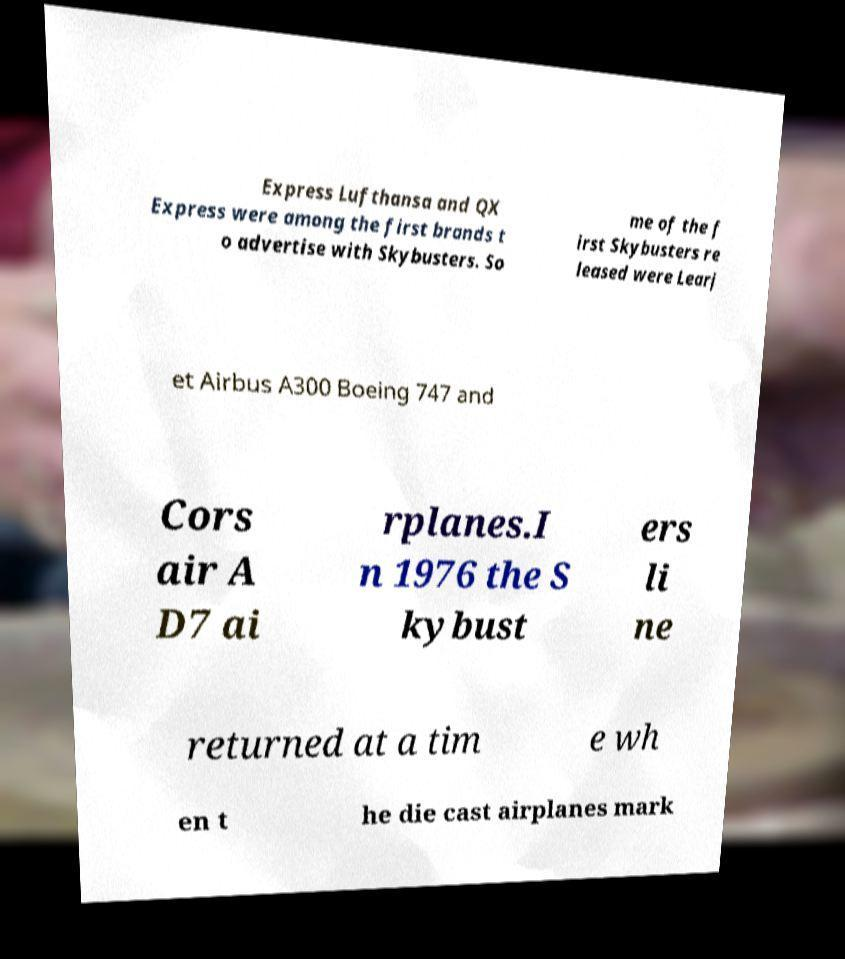What messages or text are displayed in this image? I need them in a readable, typed format. Express Lufthansa and QX Express were among the first brands t o advertise with Skybusters. So me of the f irst Skybusters re leased were Learj et Airbus A300 Boeing 747 and Cors air A D7 ai rplanes.I n 1976 the S kybust ers li ne returned at a tim e wh en t he die cast airplanes mark 